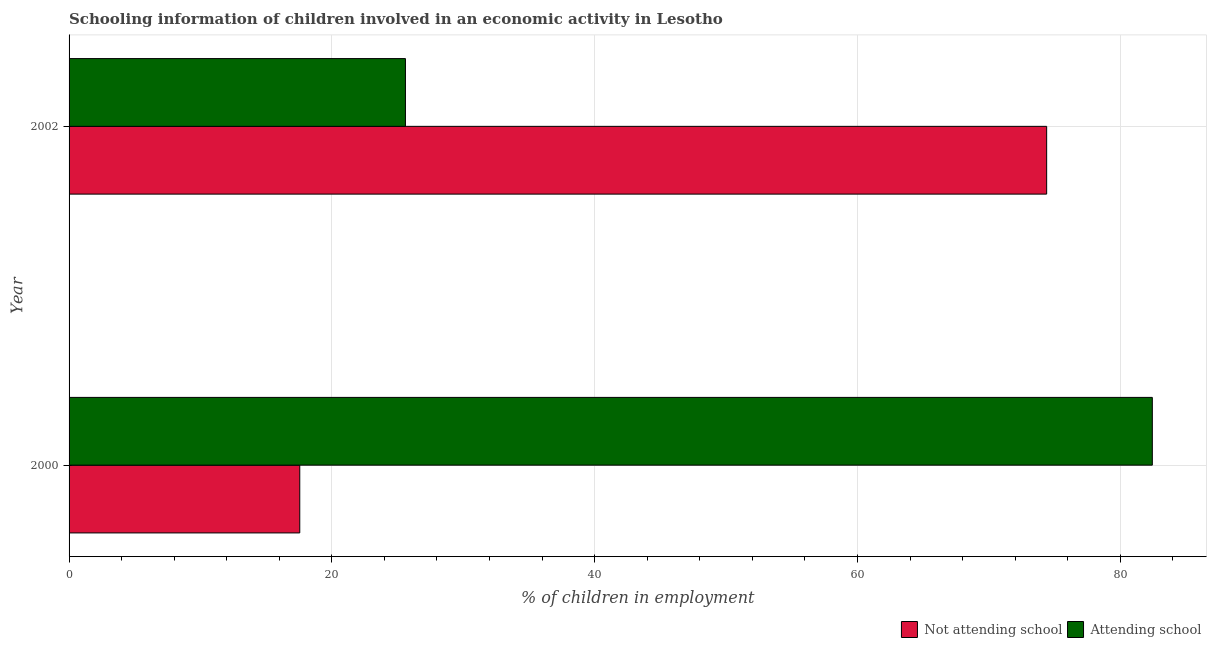How many different coloured bars are there?
Provide a succinct answer. 2. Are the number of bars on each tick of the Y-axis equal?
Your response must be concise. Yes. What is the percentage of employed children who are attending school in 2002?
Offer a terse response. 25.6. Across all years, what is the maximum percentage of employed children who are not attending school?
Ensure brevity in your answer.  74.4. Across all years, what is the minimum percentage of employed children who are not attending school?
Offer a very short reply. 17.56. In which year was the percentage of employed children who are attending school minimum?
Provide a succinct answer. 2002. What is the total percentage of employed children who are not attending school in the graph?
Keep it short and to the point. 91.96. What is the difference between the percentage of employed children who are not attending school in 2000 and that in 2002?
Your answer should be very brief. -56.84. What is the difference between the percentage of employed children who are not attending school in 2000 and the percentage of employed children who are attending school in 2002?
Keep it short and to the point. -8.04. What is the average percentage of employed children who are attending school per year?
Offer a terse response. 54.02. In the year 2002, what is the difference between the percentage of employed children who are not attending school and percentage of employed children who are attending school?
Keep it short and to the point. 48.8. In how many years, is the percentage of employed children who are attending school greater than 48 %?
Give a very brief answer. 1. What is the ratio of the percentage of employed children who are not attending school in 2000 to that in 2002?
Offer a very short reply. 0.24. Is the difference between the percentage of employed children who are attending school in 2000 and 2002 greater than the difference between the percentage of employed children who are not attending school in 2000 and 2002?
Your response must be concise. Yes. What does the 1st bar from the top in 2002 represents?
Offer a terse response. Attending school. What does the 2nd bar from the bottom in 2000 represents?
Your answer should be compact. Attending school. Are the values on the major ticks of X-axis written in scientific E-notation?
Give a very brief answer. No. Does the graph contain grids?
Provide a succinct answer. Yes. Where does the legend appear in the graph?
Your answer should be compact. Bottom right. How many legend labels are there?
Provide a short and direct response. 2. What is the title of the graph?
Your answer should be compact. Schooling information of children involved in an economic activity in Lesotho. What is the label or title of the X-axis?
Your response must be concise. % of children in employment. What is the % of children in employment in Not attending school in 2000?
Provide a short and direct response. 17.56. What is the % of children in employment of Attending school in 2000?
Provide a short and direct response. 82.44. What is the % of children in employment of Not attending school in 2002?
Your answer should be compact. 74.4. What is the % of children in employment in Attending school in 2002?
Offer a terse response. 25.6. Across all years, what is the maximum % of children in employment of Not attending school?
Your response must be concise. 74.4. Across all years, what is the maximum % of children in employment of Attending school?
Offer a terse response. 82.44. Across all years, what is the minimum % of children in employment of Not attending school?
Ensure brevity in your answer.  17.56. Across all years, what is the minimum % of children in employment of Attending school?
Your response must be concise. 25.6. What is the total % of children in employment in Not attending school in the graph?
Give a very brief answer. 91.96. What is the total % of children in employment of Attending school in the graph?
Offer a terse response. 108.04. What is the difference between the % of children in employment of Not attending school in 2000 and that in 2002?
Your answer should be compact. -56.84. What is the difference between the % of children in employment in Attending school in 2000 and that in 2002?
Provide a succinct answer. 56.84. What is the difference between the % of children in employment in Not attending school in 2000 and the % of children in employment in Attending school in 2002?
Your answer should be compact. -8.04. What is the average % of children in employment of Not attending school per year?
Your answer should be very brief. 45.98. What is the average % of children in employment in Attending school per year?
Give a very brief answer. 54.02. In the year 2000, what is the difference between the % of children in employment in Not attending school and % of children in employment in Attending school?
Ensure brevity in your answer.  -64.89. In the year 2002, what is the difference between the % of children in employment in Not attending school and % of children in employment in Attending school?
Ensure brevity in your answer.  48.8. What is the ratio of the % of children in employment in Not attending school in 2000 to that in 2002?
Make the answer very short. 0.24. What is the ratio of the % of children in employment in Attending school in 2000 to that in 2002?
Offer a very short reply. 3.22. What is the difference between the highest and the second highest % of children in employment in Not attending school?
Provide a succinct answer. 56.84. What is the difference between the highest and the second highest % of children in employment of Attending school?
Give a very brief answer. 56.84. What is the difference between the highest and the lowest % of children in employment in Not attending school?
Your response must be concise. 56.84. What is the difference between the highest and the lowest % of children in employment in Attending school?
Offer a terse response. 56.84. 